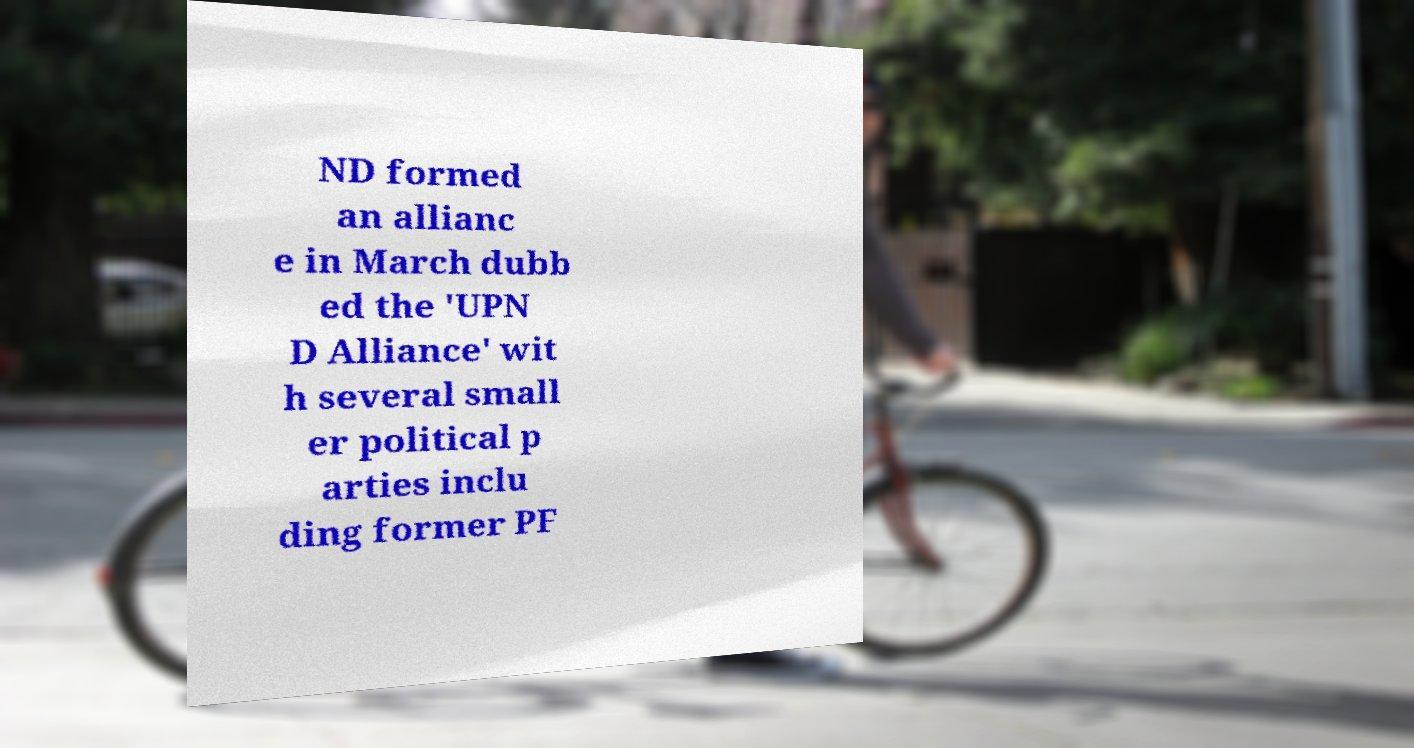Please identify and transcribe the text found in this image. ND formed an allianc e in March dubb ed the 'UPN D Alliance' wit h several small er political p arties inclu ding former PF 